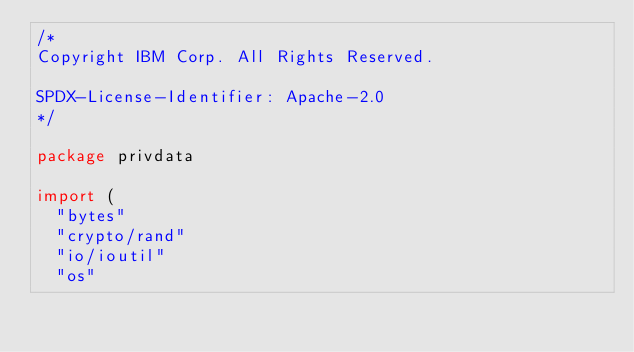<code> <loc_0><loc_0><loc_500><loc_500><_Go_>/*
Copyright IBM Corp. All Rights Reserved.

SPDX-License-Identifier: Apache-2.0
*/

package privdata

import (
	"bytes"
	"crypto/rand"
	"io/ioutil"
	"os"</code> 